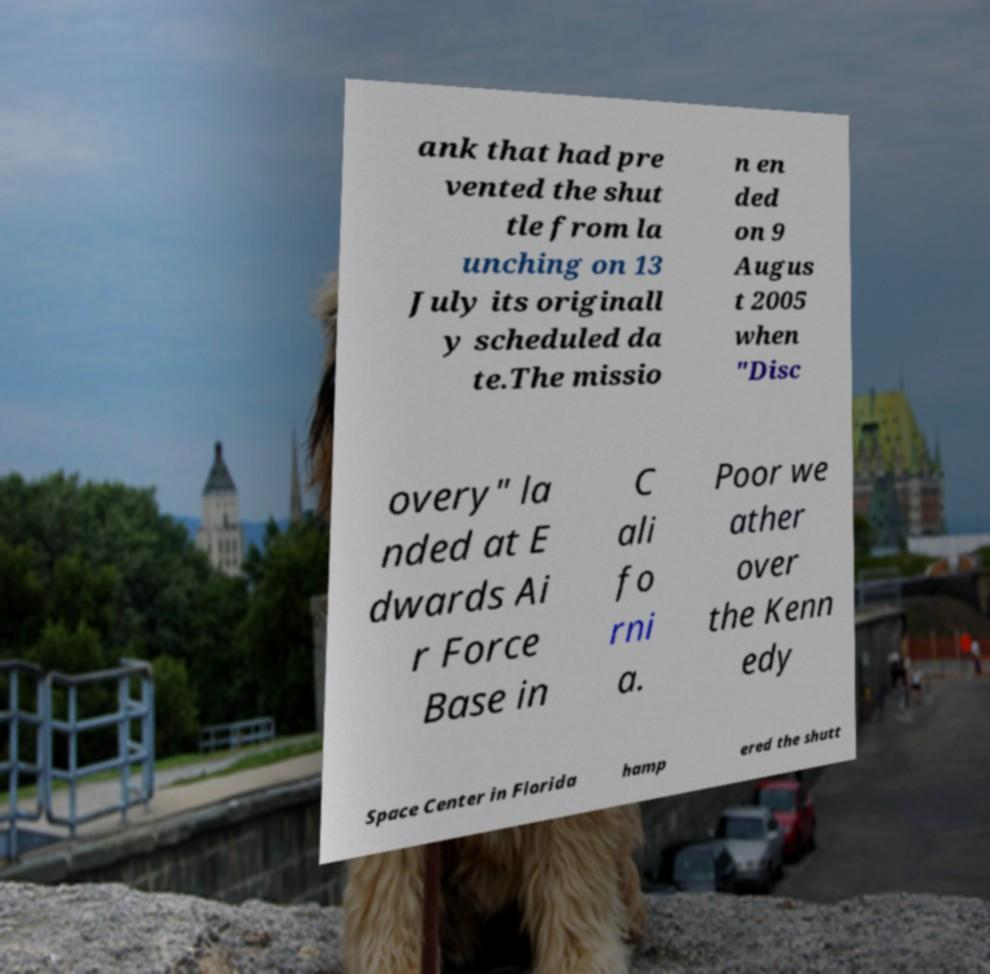Can you accurately transcribe the text from the provided image for me? ank that had pre vented the shut tle from la unching on 13 July its originall y scheduled da te.The missio n en ded on 9 Augus t 2005 when "Disc overy" la nded at E dwards Ai r Force Base in C ali fo rni a. Poor we ather over the Kenn edy Space Center in Florida hamp ered the shutt 